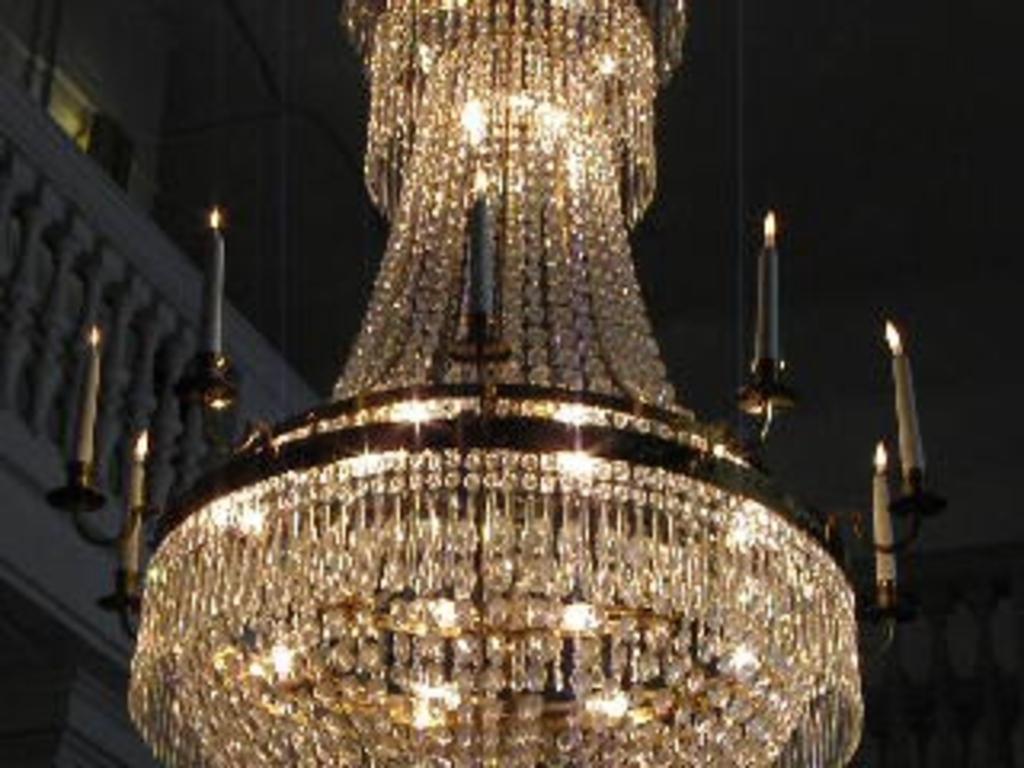Describe this image in one or two sentences. In this image, we can see a light and some candles. We can see the wall and the fence. 